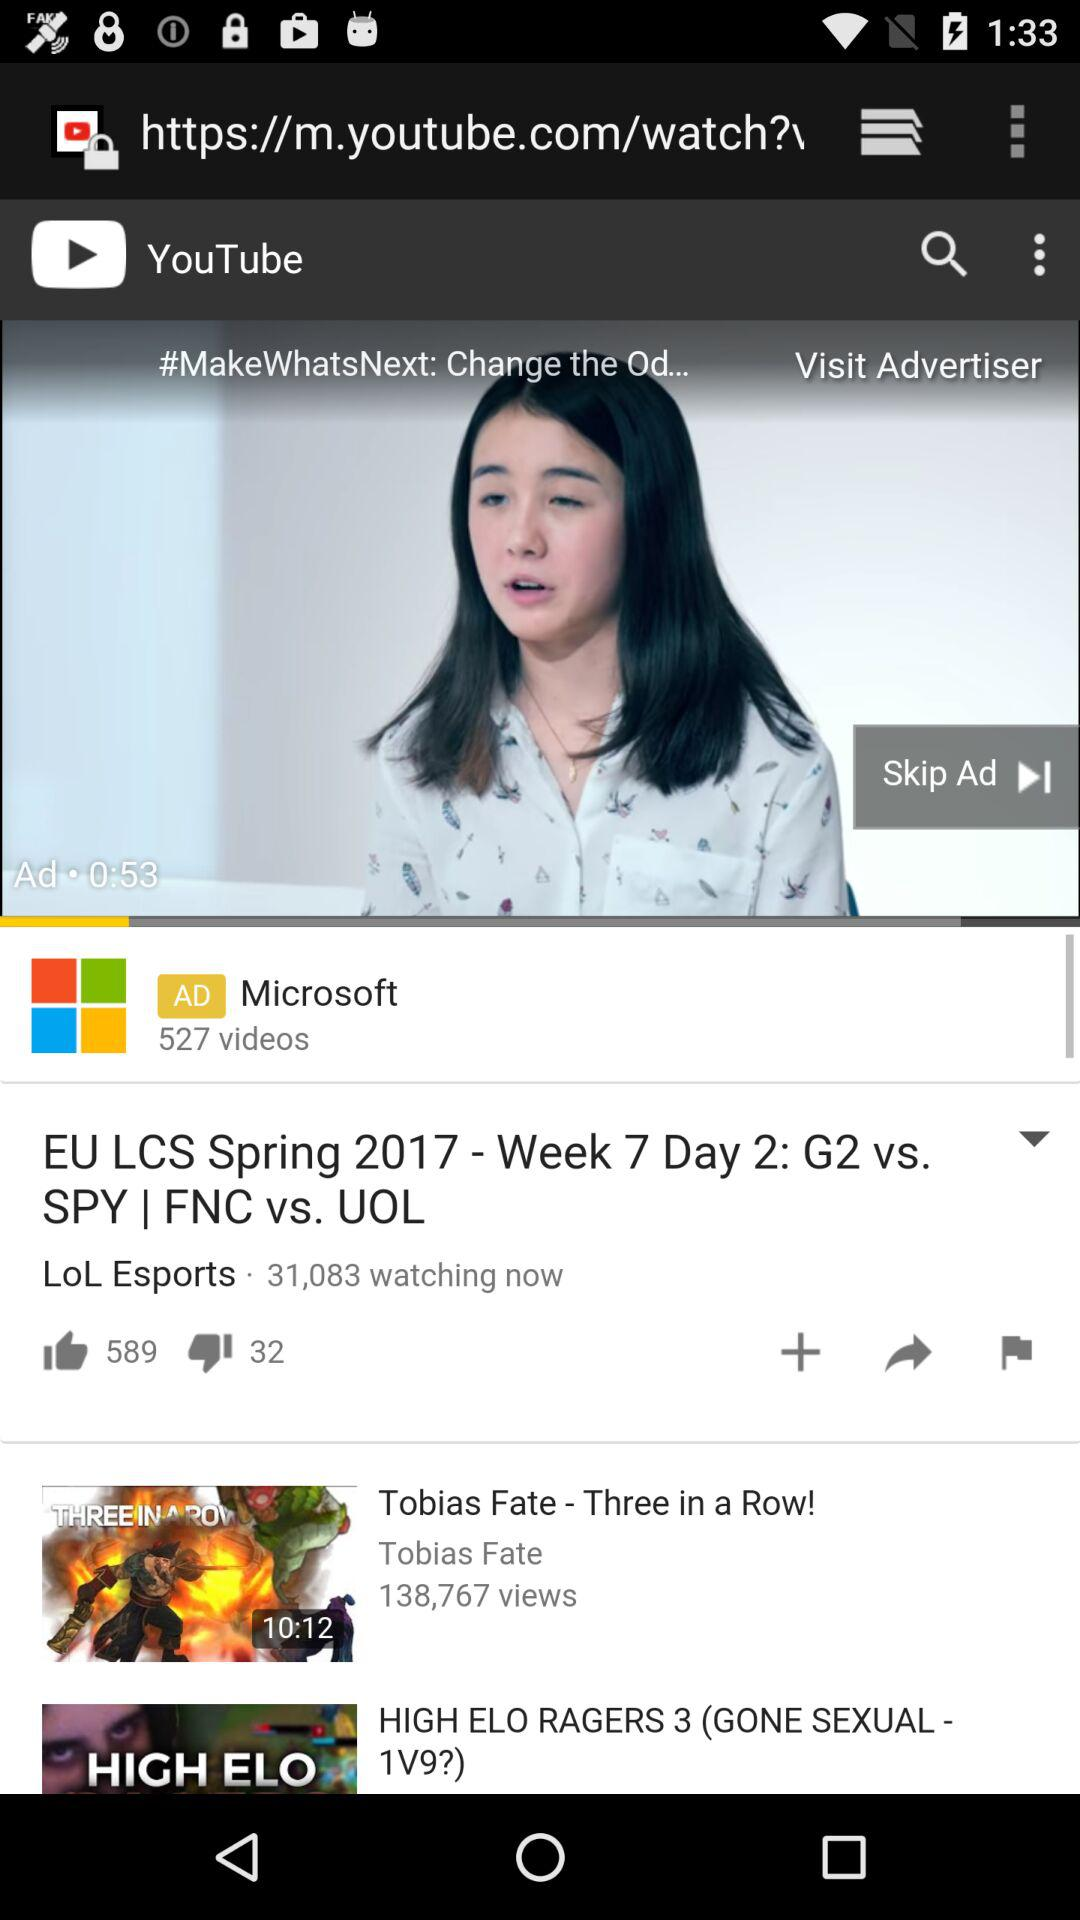How many people are watching "LOL Esports"? There are 31,083 people. 